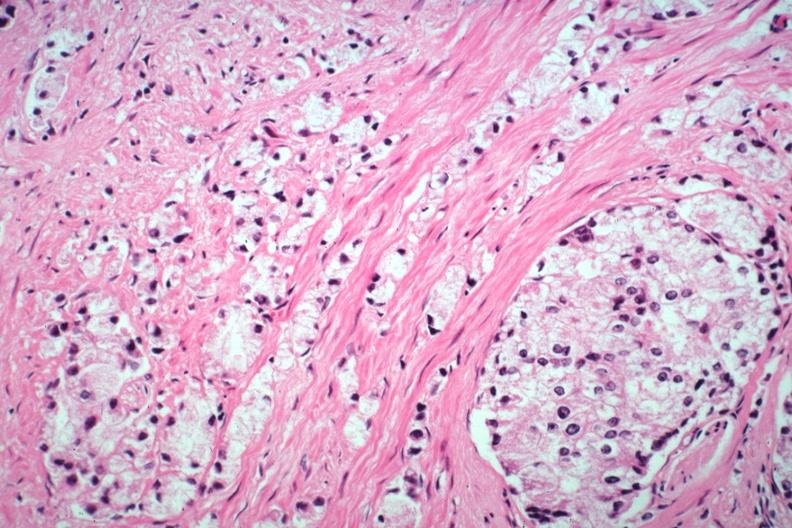what is present?
Answer the question using a single word or phrase. Adenocarcinoma 